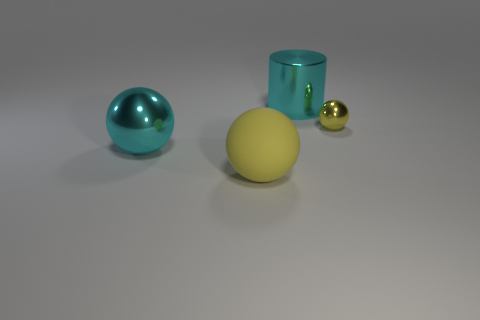What shape is the yellow object that is the same size as the cyan ball?
Your response must be concise. Sphere. Is there another ball that has the same color as the tiny sphere?
Your answer should be very brief. Yes. Does the rubber thing have the same shape as the small metal thing?
Provide a succinct answer. Yes. What number of small objects are either green matte objects or metallic spheres?
Your answer should be compact. 1. What color is the tiny thing that is made of the same material as the large cylinder?
Provide a short and direct response. Yellow. What number of small yellow objects have the same material as the large cyan cylinder?
Your answer should be very brief. 1. There is a cyan object left of the large yellow object; is its size the same as the object that is right of the large cyan cylinder?
Ensure brevity in your answer.  No. There is a yellow thing that is left of the cyan shiny object behind the tiny yellow sphere; what is it made of?
Keep it short and to the point. Rubber. Are there fewer cylinders behind the large cyan shiny cylinder than small yellow balls left of the tiny yellow metallic sphere?
Provide a short and direct response. No. What is the material of the other ball that is the same color as the tiny ball?
Keep it short and to the point. Rubber. 